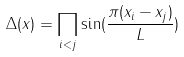Convert formula to latex. <formula><loc_0><loc_0><loc_500><loc_500>\Delta ( x ) = \prod _ { i < j } \sin ( \frac { \pi ( x _ { i } - x _ { j } ) } { L } )</formula> 